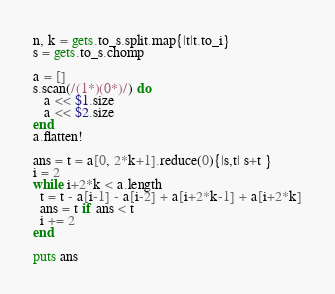Convert code to text. <code><loc_0><loc_0><loc_500><loc_500><_Ruby_>n, k = gets.to_s.split.map{|t|t.to_i}
s = gets.to_s.chomp

a = []
s.scan(/(1*)(0*)/) do 
   a << $1.size
   a << $2.size
end
a.flatten!

ans = t = a[0, 2*k+1].reduce(0){|s,t| s+t }
i = 2
while i+2*k < a.length
  t = t - a[i-1] - a[i-2] + a[i+2*k-1] + a[i+2*k]
  ans = t if ans < t
  i += 2
end
 
puts ans</code> 